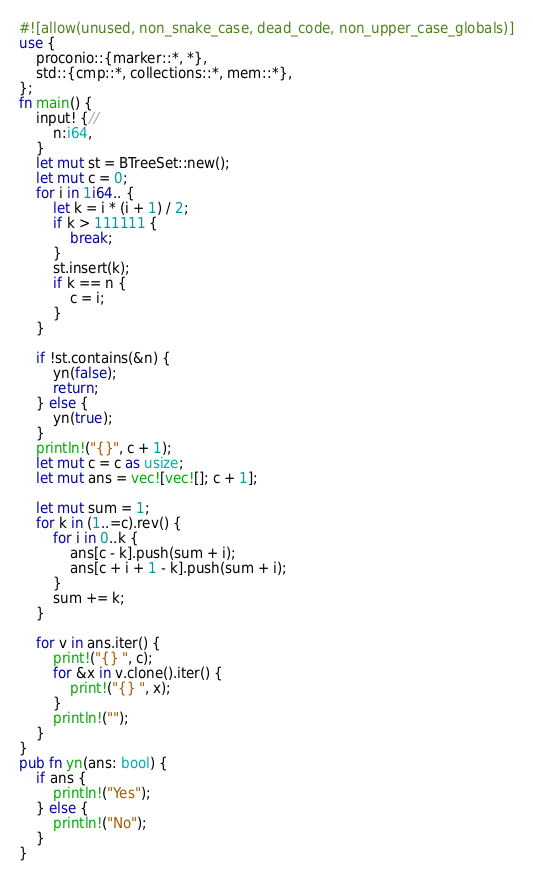Convert code to text. <code><loc_0><loc_0><loc_500><loc_500><_Rust_>#![allow(unused, non_snake_case, dead_code, non_upper_case_globals)]
use {
    proconio::{marker::*, *},
    std::{cmp::*, collections::*, mem::*},
};
fn main() {
    input! {//
        n:i64,
    }
    let mut st = BTreeSet::new();
    let mut c = 0;
    for i in 1i64.. {
        let k = i * (i + 1) / 2;
        if k > 111111 {
            break;
        }
        st.insert(k);
        if k == n {
            c = i;
        }
    }

    if !st.contains(&n) {
        yn(false);
        return;
    } else {
        yn(true);
    }
    println!("{}", c + 1);
    let mut c = c as usize;
    let mut ans = vec![vec![]; c + 1];

    let mut sum = 1;
    for k in (1..=c).rev() {
        for i in 0..k {
            ans[c - k].push(sum + i);
            ans[c + i + 1 - k].push(sum + i);
        }
        sum += k;
    }

    for v in ans.iter() {
        print!("{} ", c);
        for &x in v.clone().iter() {
            print!("{} ", x);
        }
        println!("");
    }
}
pub fn yn(ans: bool) {
    if ans {
        println!("Yes");
    } else {
        println!("No");
    }
}
</code> 